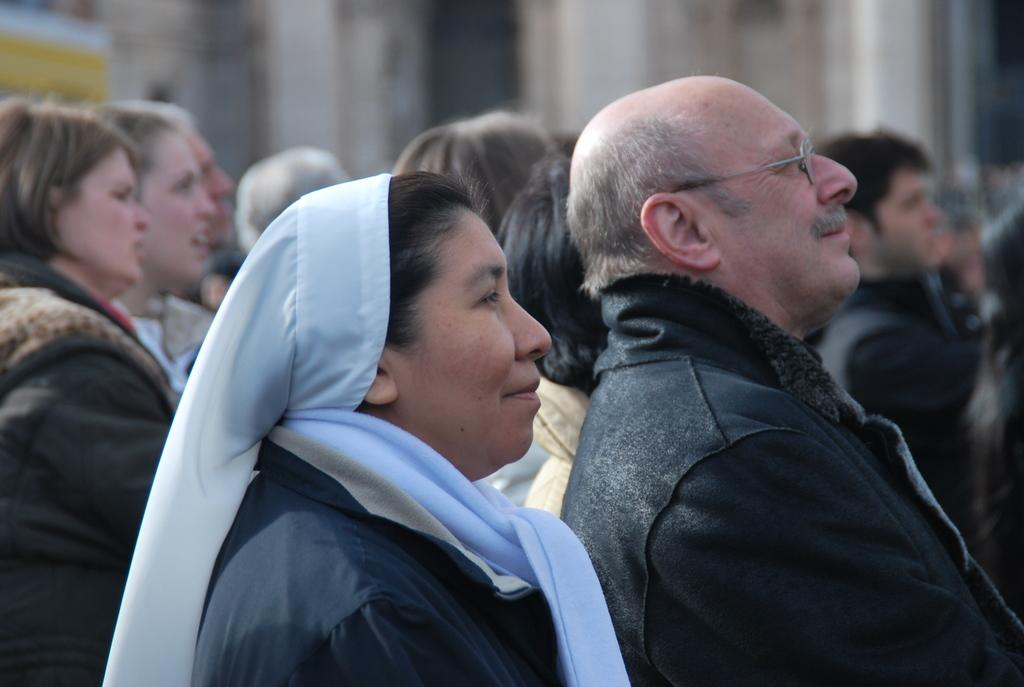How many people are in the image? There is a group of persons in the image. Can you describe the position of one of the persons in the image? There is a person truncated towards the left side of the image. What is the appearance of the background in the image? The background of the image is blurred. What word is written on the person's shirt in the image? There is no word visible on the person's shirt in the image. What season is depicted in the image? The image does not depict a specific season, as there are no seasonal cues present. 